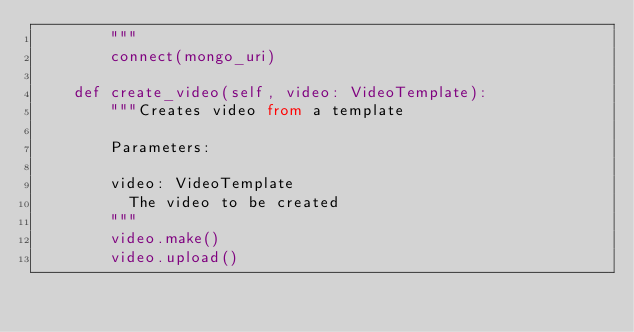Convert code to text. <code><loc_0><loc_0><loc_500><loc_500><_Python_>        """
        connect(mongo_uri)
    
    def create_video(self, video: VideoTemplate):
        """Creates video from a template

        Parameters:

        video: VideoTemplate
          The video to be created
        """
        video.make()
        video.upload()</code> 